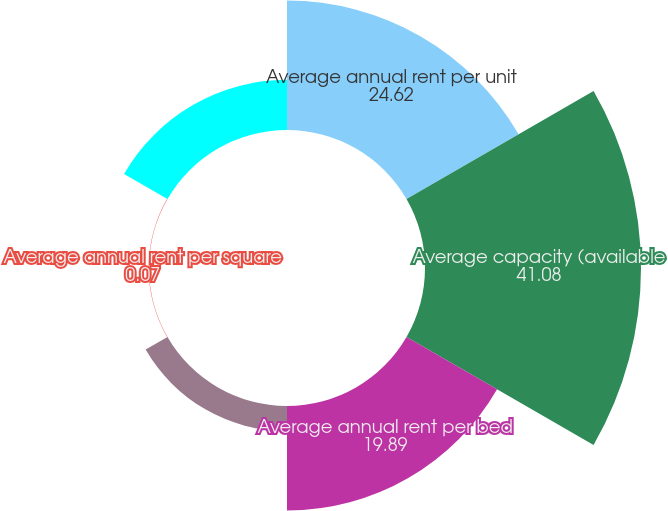Convert chart to OTSL. <chart><loc_0><loc_0><loc_500><loc_500><pie_chart><fcel>Average annual rent per unit<fcel>Average capacity (available<fcel>Average annual rent per bed<fcel>Average occupancy percentage<fcel>Average annual rent per square<fcel>Average occupied square feet<nl><fcel>24.62%<fcel>41.08%<fcel>19.89%<fcel>4.8%<fcel>0.07%<fcel>9.54%<nl></chart> 